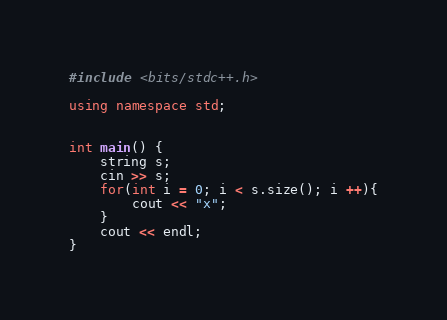Convert code to text. <code><loc_0><loc_0><loc_500><loc_500><_C++_>#include <bits/stdc++.h>

using namespace std;


int main() {
    string s;
    cin >> s;
    for(int i = 0; i < s.size(); i ++){
        cout << "x";
    }
    cout << endl;
}</code> 